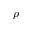Convert formula to latex. <formula><loc_0><loc_0><loc_500><loc_500>\rho</formula> 